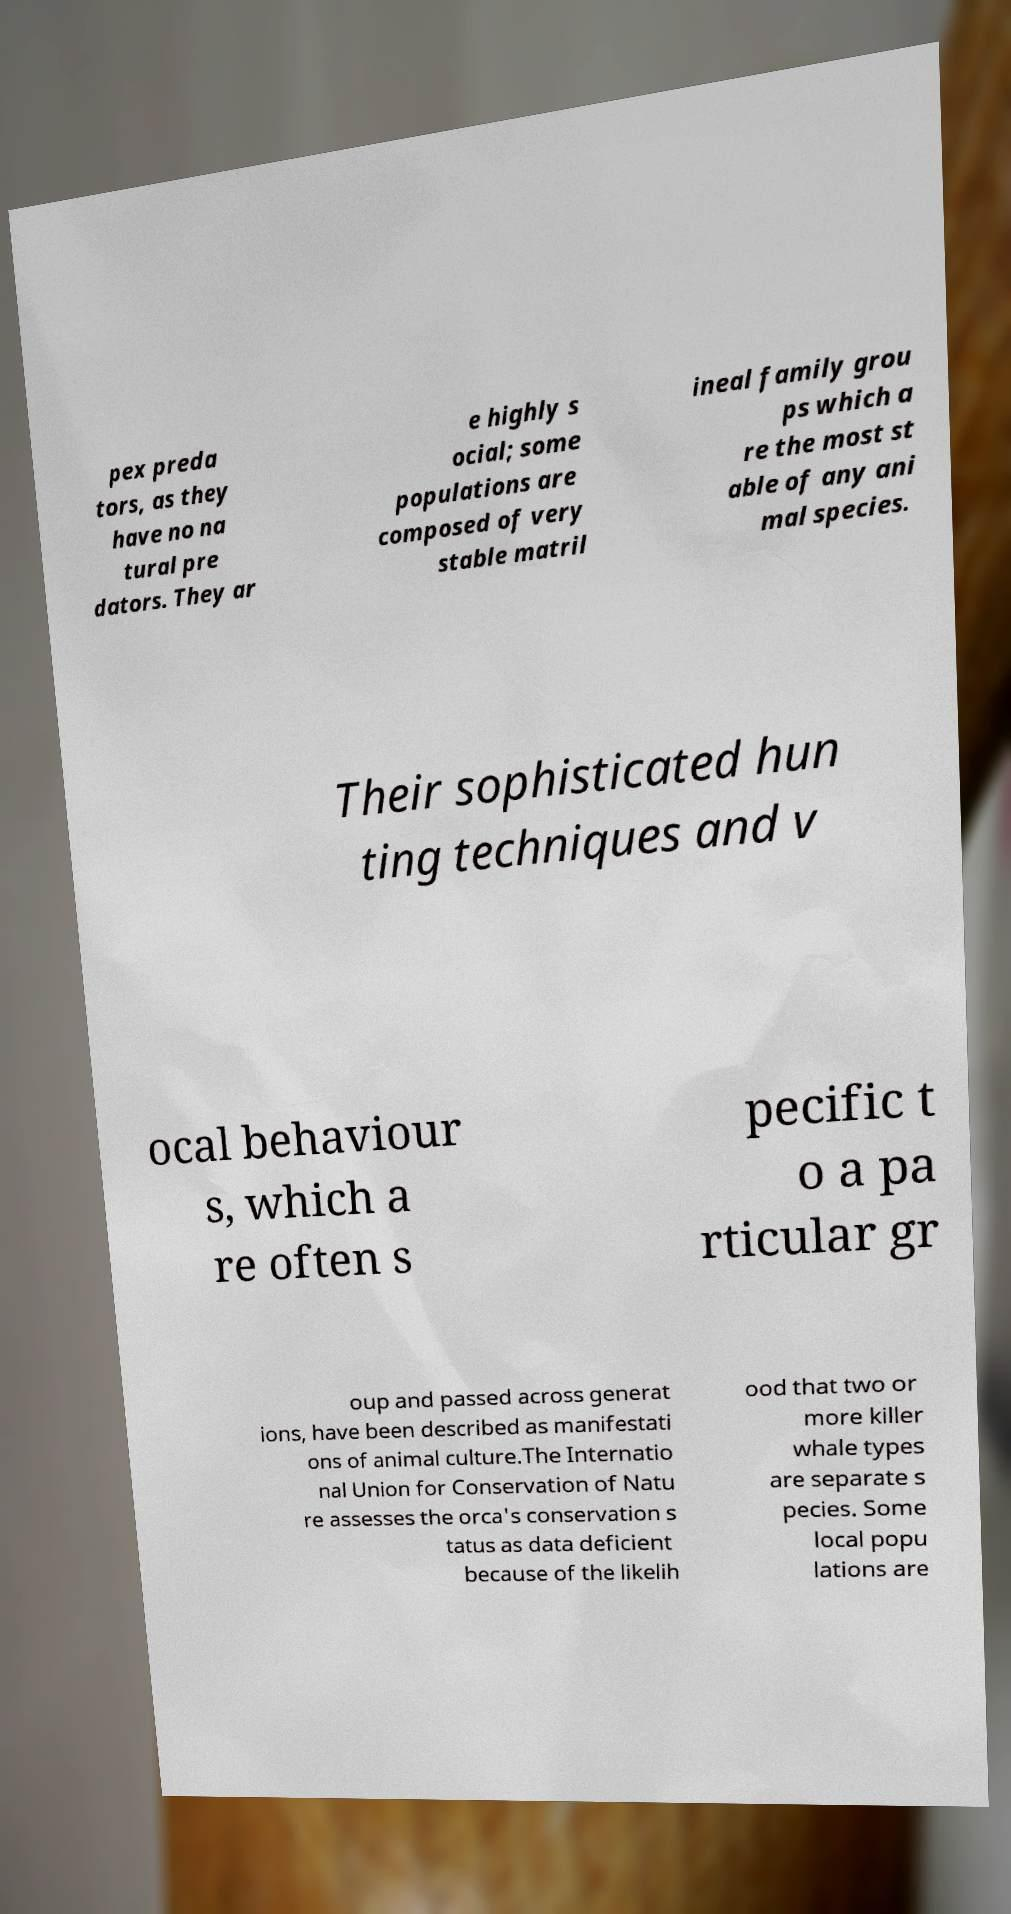What messages or text are displayed in this image? I need them in a readable, typed format. pex preda tors, as they have no na tural pre dators. They ar e highly s ocial; some populations are composed of very stable matril ineal family grou ps which a re the most st able of any ani mal species. Their sophisticated hun ting techniques and v ocal behaviour s, which a re often s pecific t o a pa rticular gr oup and passed across generat ions, have been described as manifestati ons of animal culture.The Internatio nal Union for Conservation of Natu re assesses the orca's conservation s tatus as data deficient because of the likelih ood that two or more killer whale types are separate s pecies. Some local popu lations are 